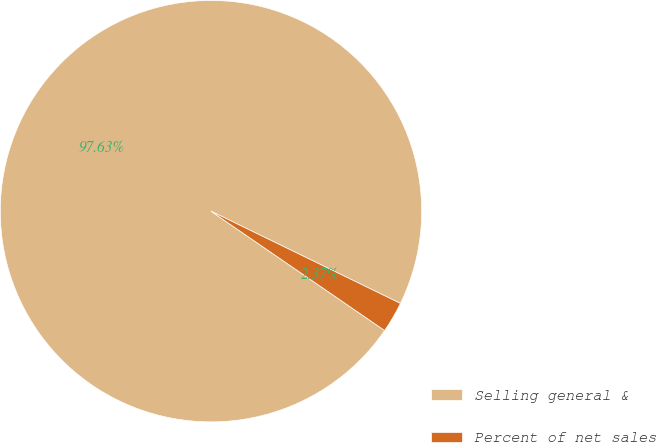Convert chart to OTSL. <chart><loc_0><loc_0><loc_500><loc_500><pie_chart><fcel>Selling general &<fcel>Percent of net sales<nl><fcel>97.63%<fcel>2.37%<nl></chart> 